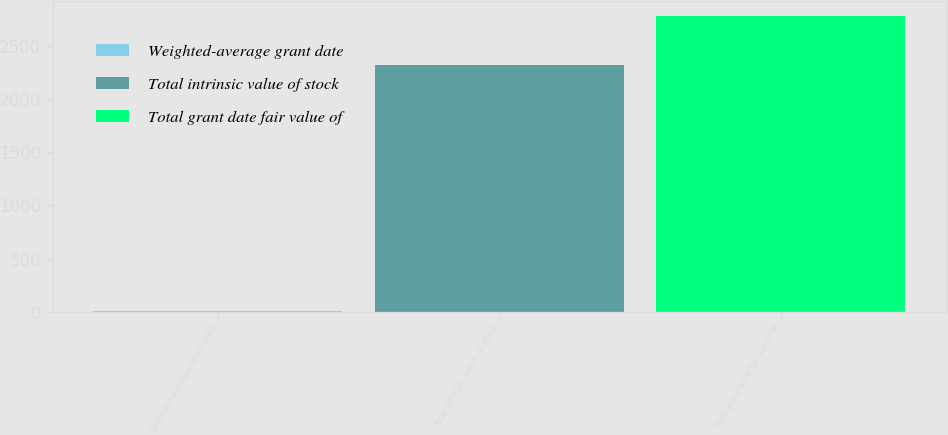Convert chart to OTSL. <chart><loc_0><loc_0><loc_500><loc_500><bar_chart><fcel>Weighted-average grant date<fcel>Total intrinsic value of stock<fcel>Total grant date fair value of<nl><fcel>10.83<fcel>2323<fcel>2784<nl></chart> 